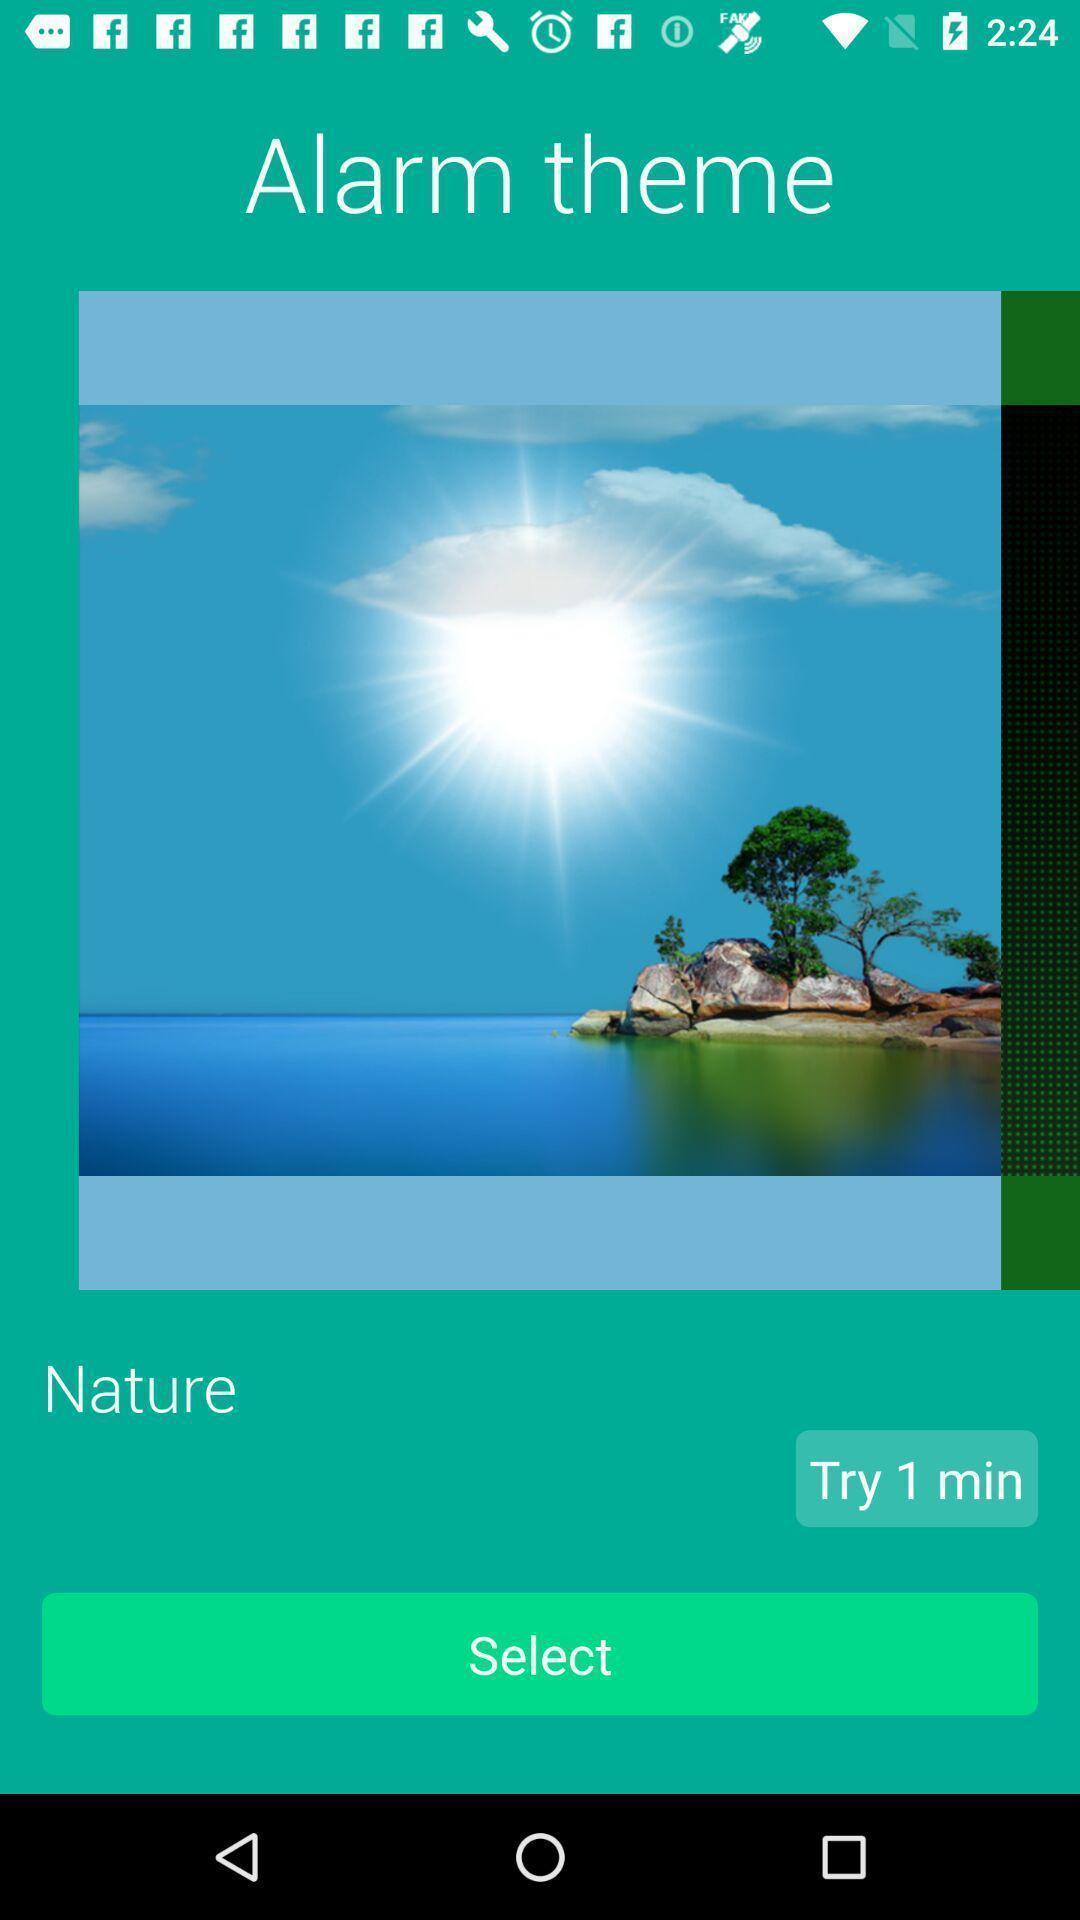Provide a detailed account of this screenshot. Page showing to set the alarm theme. 